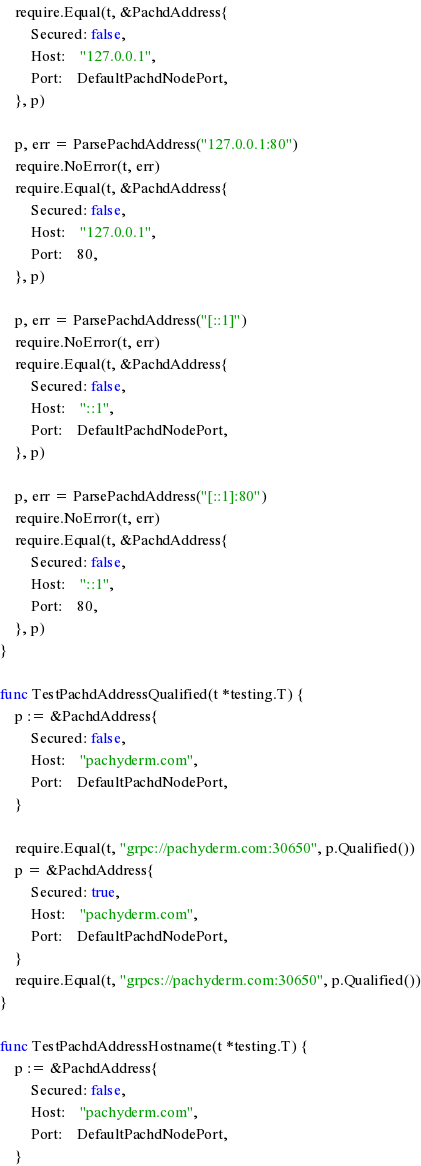Convert code to text. <code><loc_0><loc_0><loc_500><loc_500><_Go_>	require.Equal(t, &PachdAddress{
		Secured: false,
		Host:    "127.0.0.1",
		Port:    DefaultPachdNodePort,
	}, p)

	p, err = ParsePachdAddress("127.0.0.1:80")
	require.NoError(t, err)
	require.Equal(t, &PachdAddress{
		Secured: false,
		Host:    "127.0.0.1",
		Port:    80,
	}, p)

	p, err = ParsePachdAddress("[::1]")
	require.NoError(t, err)
	require.Equal(t, &PachdAddress{
		Secured: false,
		Host:    "::1",
		Port:    DefaultPachdNodePort,
	}, p)

	p, err = ParsePachdAddress("[::1]:80")
	require.NoError(t, err)
	require.Equal(t, &PachdAddress{
		Secured: false,
		Host:    "::1",
		Port:    80,
	}, p)
}

func TestPachdAddressQualified(t *testing.T) {
	p := &PachdAddress{
		Secured: false,
		Host:    "pachyderm.com",
		Port:    DefaultPachdNodePort,
	}

	require.Equal(t, "grpc://pachyderm.com:30650", p.Qualified())
	p = &PachdAddress{
		Secured: true,
		Host:    "pachyderm.com",
		Port:    DefaultPachdNodePort,
	}
	require.Equal(t, "grpcs://pachyderm.com:30650", p.Qualified())
}

func TestPachdAddressHostname(t *testing.T) {
	p := &PachdAddress{
		Secured: false,
		Host:    "pachyderm.com",
		Port:    DefaultPachdNodePort,
	}</code> 